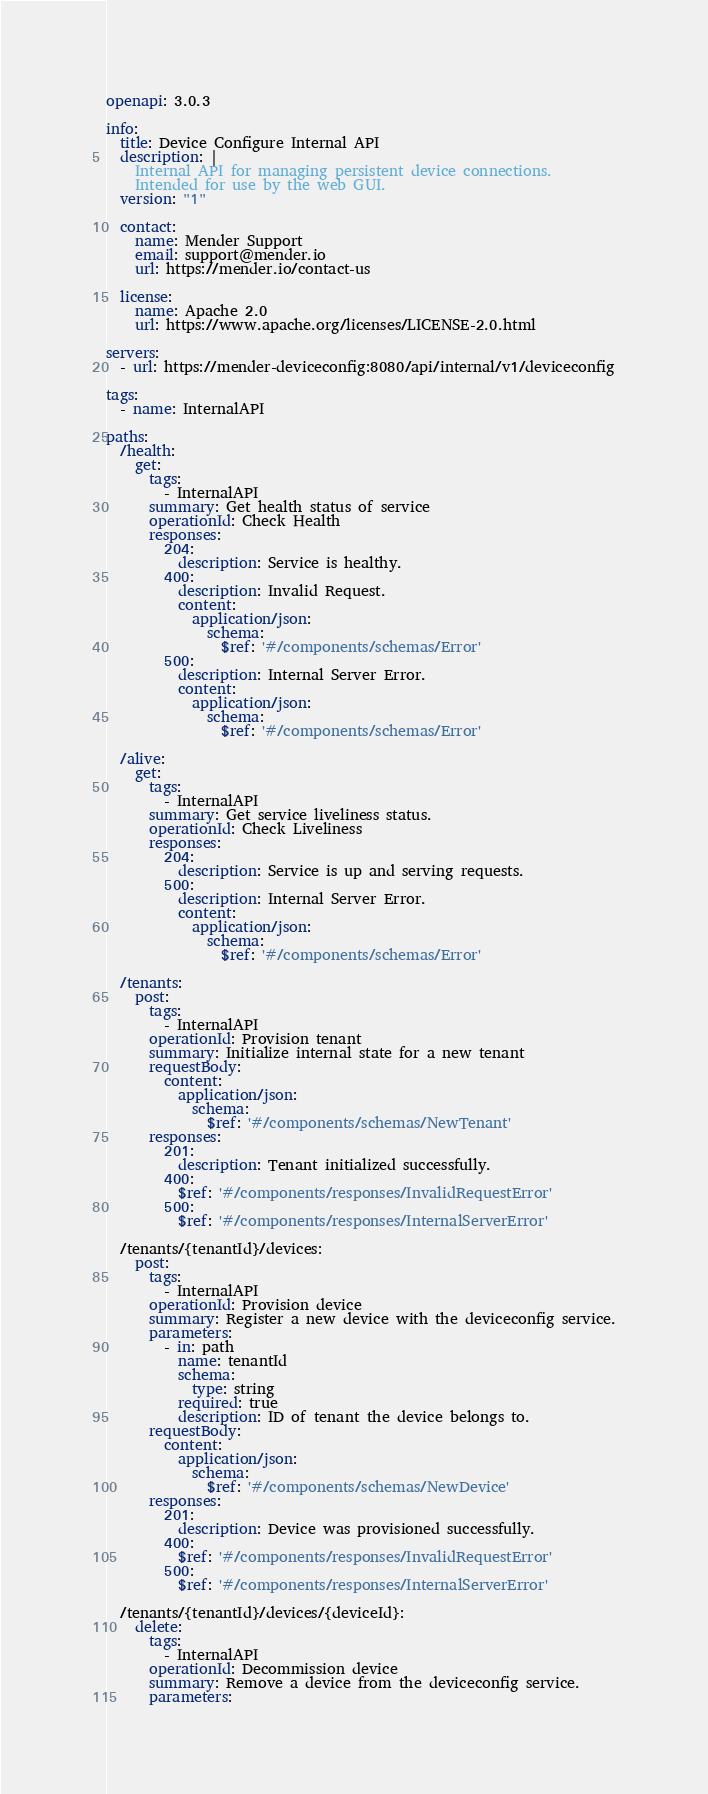Convert code to text. <code><loc_0><loc_0><loc_500><loc_500><_YAML_>openapi: 3.0.3

info:
  title: Device Configure Internal API
  description: |
    Internal API for managing persistent device connections.
    Intended for use by the web GUI.
  version: "1"

  contact:
    name: Mender Support
    email: support@mender.io
    url: https://mender.io/contact-us

  license:
    name: Apache 2.0
    url: https://www.apache.org/licenses/LICENSE-2.0.html

servers:
  - url: https://mender-deviceconfig:8080/api/internal/v1/deviceconfig

tags:
  - name: InternalAPI

paths:
  /health:
    get:
      tags:
        - InternalAPI
      summary: Get health status of service
      operationId: Check Health
      responses:
        204:
          description: Service is healthy.
        400:
          description: Invalid Request.
          content:
            application/json:
              schema:
                $ref: '#/components/schemas/Error'
        500:
          description: Internal Server Error.
          content:
            application/json:
              schema:
                $ref: '#/components/schemas/Error'

  /alive:
    get:
      tags:
        - InternalAPI
      summary: Get service liveliness status.
      operationId: Check Liveliness
      responses:
        204:
          description: Service is up and serving requests.
        500:
          description: Internal Server Error.
          content:
            application/json:
              schema:
                $ref: '#/components/schemas/Error'

  /tenants:
    post:
      tags:
        - InternalAPI
      operationId: Provision tenant
      summary: Initialize internal state for a new tenant
      requestBody:
        content:
          application/json:
            schema:
              $ref: '#/components/schemas/NewTenant'
      responses:
        201:
          description: Tenant initialized successfully.
        400:
          $ref: '#/components/responses/InvalidRequestError'
        500:
          $ref: '#/components/responses/InternalServerError'

  /tenants/{tenantId}/devices:
    post:
      tags:
        - InternalAPI
      operationId: Provision device
      summary: Register a new device with the deviceconfig service.
      parameters:
        - in: path
          name: tenantId
          schema:
            type: string
          required: true
          description: ID of tenant the device belongs to.
      requestBody:
        content:
          application/json:
            schema:
              $ref: '#/components/schemas/NewDevice'
      responses:
        201:
          description: Device was provisioned successfully.
        400:
          $ref: '#/components/responses/InvalidRequestError'
        500:
          $ref: '#/components/responses/InternalServerError'

  /tenants/{tenantId}/devices/{deviceId}:
    delete:
      tags:
        - InternalAPI
      operationId: Decommission device
      summary: Remove a device from the deviceconfig service.
      parameters:</code> 